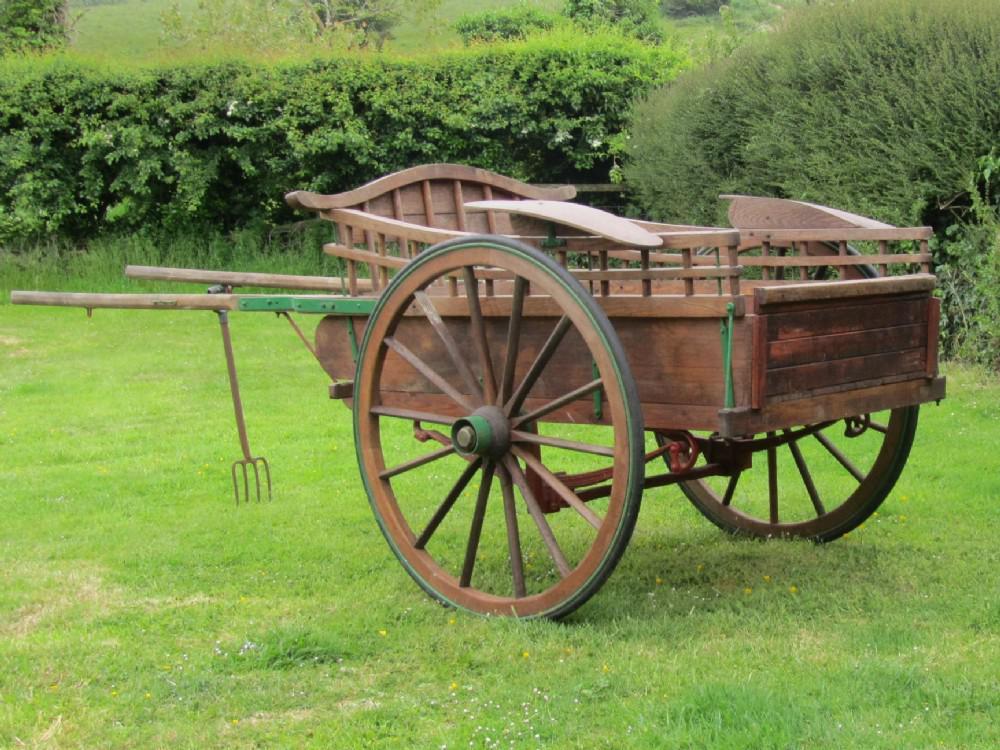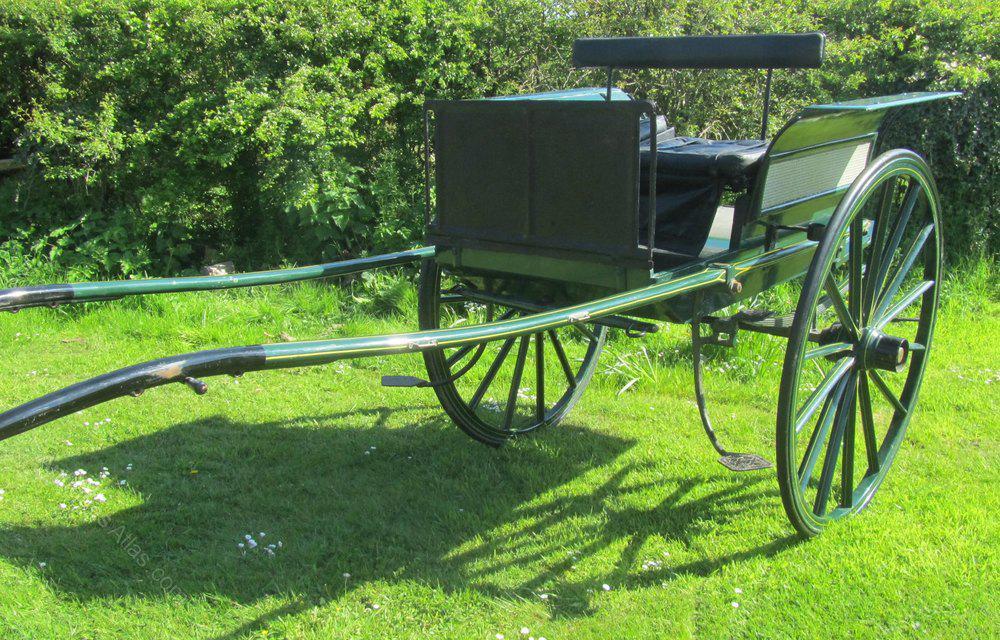The first image is the image on the left, the second image is the image on the right. Assess this claim about the two images: "At least one image shows a two-wheeled cart with no passengers, parked on green grass.". Correct or not? Answer yes or no. Yes. The first image is the image on the left, the second image is the image on the right. Assess this claim about the two images: "There is a two wheel cart in at least one of the images.". Correct or not? Answer yes or no. Yes. 